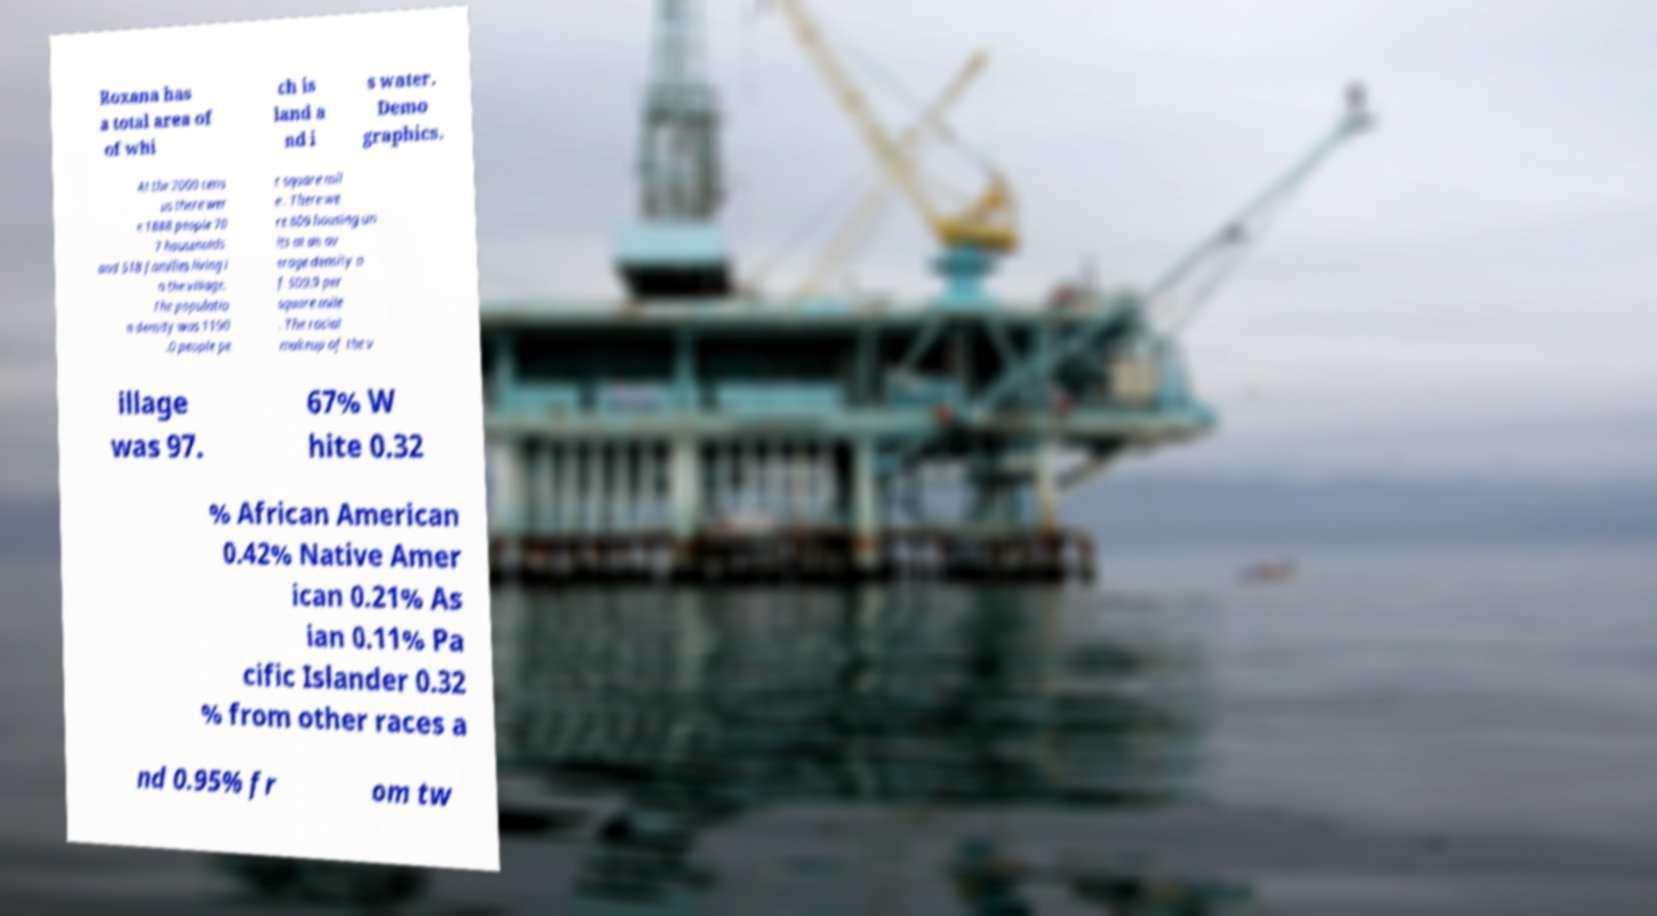Could you assist in decoding the text presented in this image and type it out clearly? Roxana has a total area of of whi ch is land a nd i s water. Demo graphics. At the 2000 cens us there wer e 1888 people 70 7 households and 518 families living i n the village. The populatio n density was 1190 .0 people pe r square mil e . There we re 809 housing un its at an av erage density o f 509.9 per square mile . The racial makeup of the v illage was 97. 67% W hite 0.32 % African American 0.42% Native Amer ican 0.21% As ian 0.11% Pa cific Islander 0.32 % from other races a nd 0.95% fr om tw 